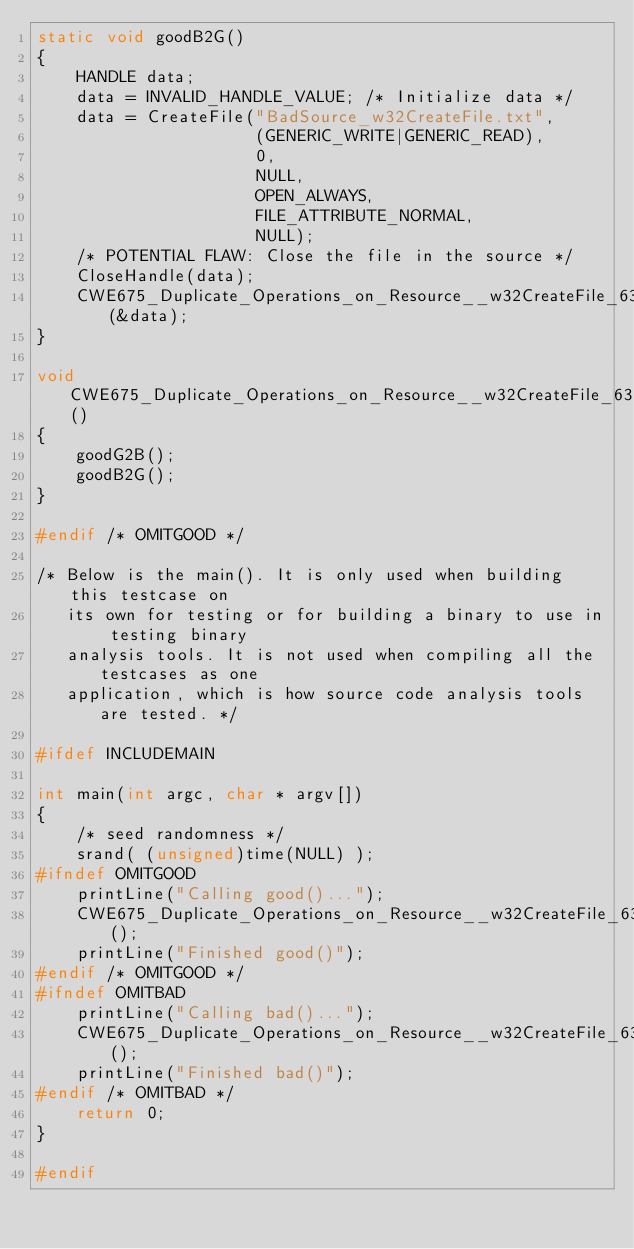<code> <loc_0><loc_0><loc_500><loc_500><_C_>static void goodB2G()
{
    HANDLE data;
    data = INVALID_HANDLE_VALUE; /* Initialize data */
    data = CreateFile("BadSource_w32CreateFile.txt",
                      (GENERIC_WRITE|GENERIC_READ),
                      0,
                      NULL,
                      OPEN_ALWAYS,
                      FILE_ATTRIBUTE_NORMAL,
                      NULL);
    /* POTENTIAL FLAW: Close the file in the source */
    CloseHandle(data);
    CWE675_Duplicate_Operations_on_Resource__w32CreateFile_63b_goodB2G_sink(&data);
}

void CWE675_Duplicate_Operations_on_Resource__w32CreateFile_63_good()
{
    goodG2B();
    goodB2G();
}

#endif /* OMITGOOD */

/* Below is the main(). It is only used when building this testcase on
   its own for testing or for building a binary to use in testing binary
   analysis tools. It is not used when compiling all the testcases as one
   application, which is how source code analysis tools are tested. */

#ifdef INCLUDEMAIN

int main(int argc, char * argv[])
{
    /* seed randomness */
    srand( (unsigned)time(NULL) );
#ifndef OMITGOOD
    printLine("Calling good()...");
    CWE675_Duplicate_Operations_on_Resource__w32CreateFile_63_good();
    printLine("Finished good()");
#endif /* OMITGOOD */
#ifndef OMITBAD
    printLine("Calling bad()...");
    CWE675_Duplicate_Operations_on_Resource__w32CreateFile_63_bad();
    printLine("Finished bad()");
#endif /* OMITBAD */
    return 0;
}

#endif
</code> 